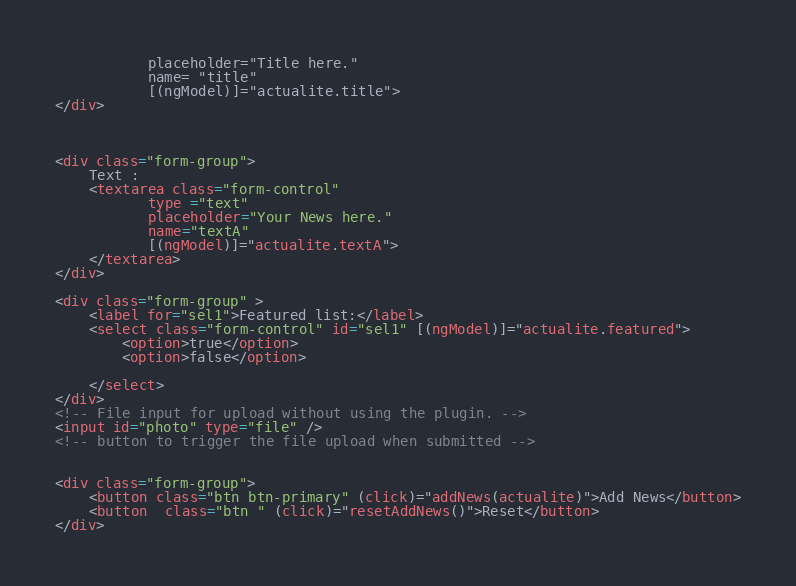<code> <loc_0><loc_0><loc_500><loc_500><_HTML_>           placeholder="Title here."
           name= "title"
           [(ngModel)]="actualite.title">
</div>



<div class="form-group">
    Text :
    <textarea class="form-control"
           type ="text"
           placeholder="Your News here."
           name="textA"
           [(ngModel)]="actualite.textA">
    </textarea>
</div>

<div class="form-group" >
    <label for="sel1">Featured list:</label>
    <select class="form-control" id="sel1" [(ngModel)]="actualite.featured">
        <option>true</option>
        <option>false</option>

    </select>
</div>
<!-- File input for upload without using the plugin. -->
<input id="photo" type="file" />
<!-- button to trigger the file upload when submitted -->


<div class="form-group">
    <button class="btn btn-primary" (click)="addNews(actualite)">Add News</button>
    <button  class="btn " (click)="resetAddNews()">Reset</button>
</div></code> 